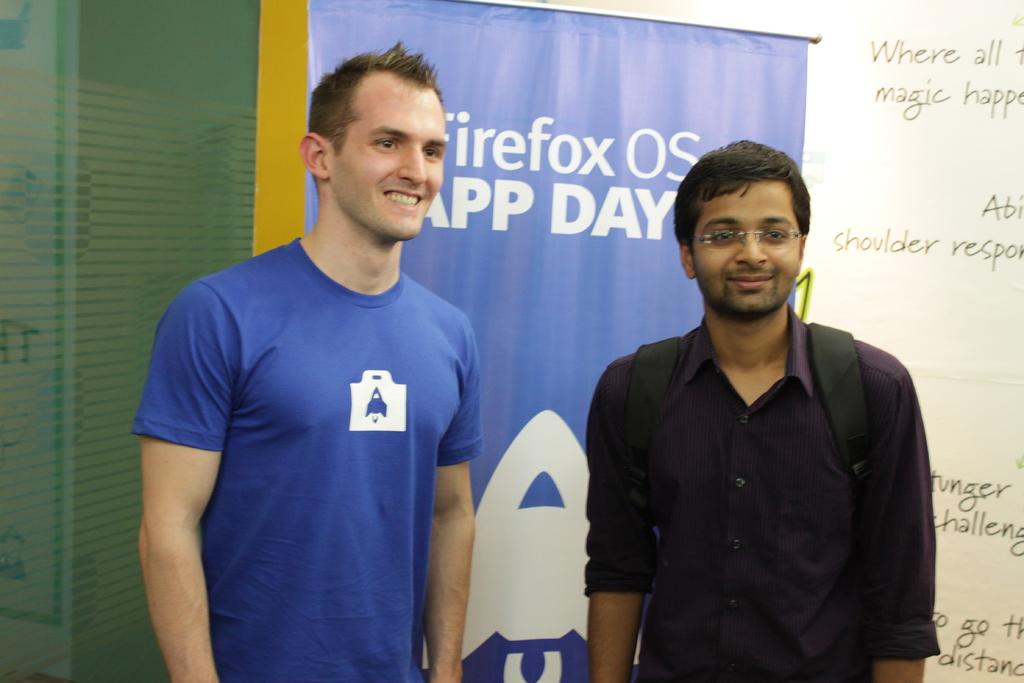Provide a one-sentence caption for the provided image. Two men stand side by side in front of a Firefox banner. 